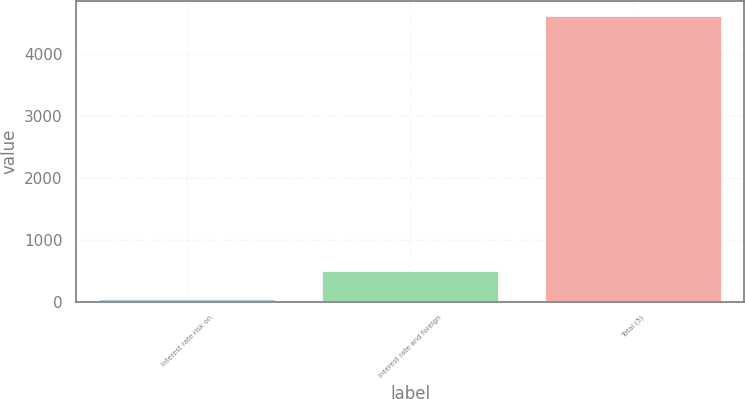Convert chart. <chart><loc_0><loc_0><loc_500><loc_500><bar_chart><fcel>Interest rate risk on<fcel>Interest rate and foreign<fcel>Total (5)<nl><fcel>51<fcel>509.7<fcel>4638<nl></chart> 